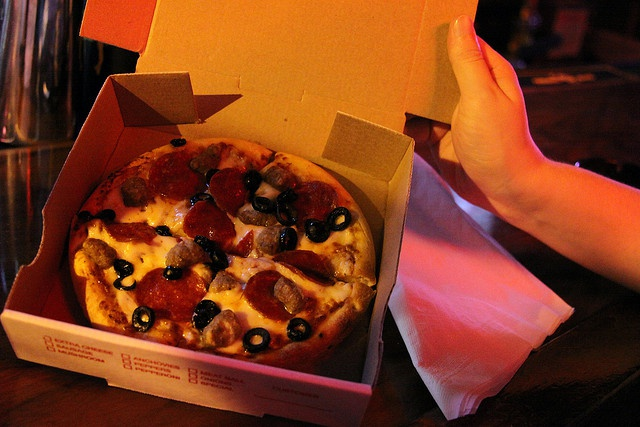Describe the objects in this image and their specific colors. I can see pizza in black, maroon, and brown tones, dining table in black, maroon, and gray tones, and people in black, red, orange, brown, and maroon tones in this image. 